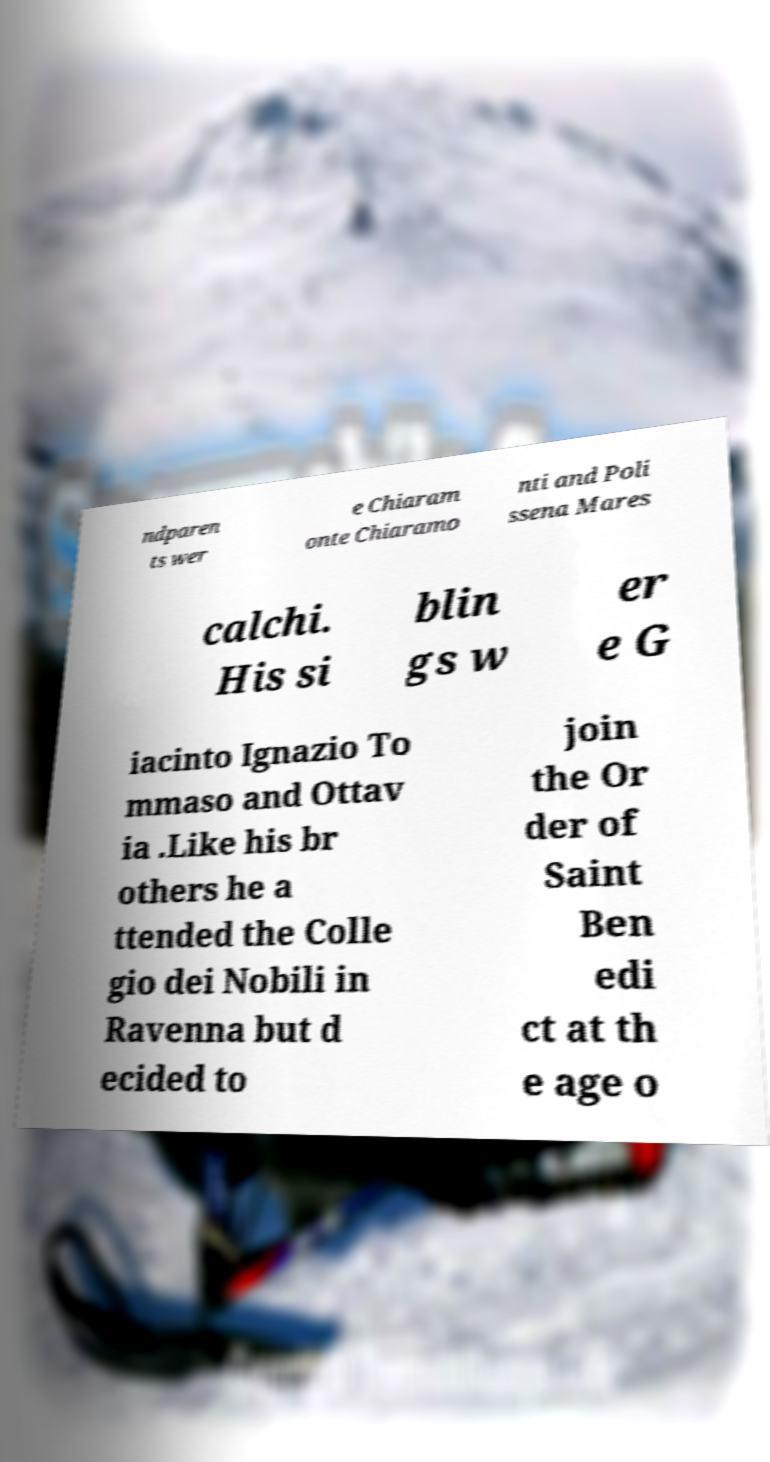Can you accurately transcribe the text from the provided image for me? ndparen ts wer e Chiaram onte Chiaramo nti and Poli ssena Mares calchi. His si blin gs w er e G iacinto Ignazio To mmaso and Ottav ia .Like his br others he a ttended the Colle gio dei Nobili in Ravenna but d ecided to join the Or der of Saint Ben edi ct at th e age o 